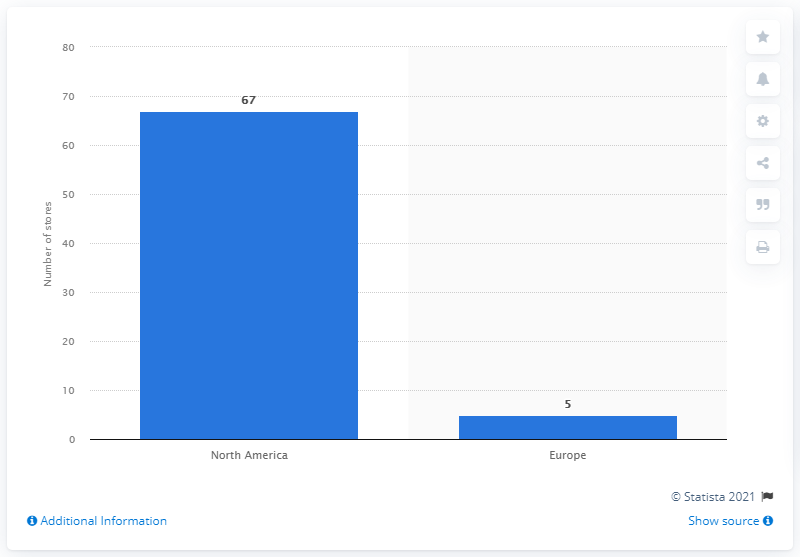Specify some key components in this picture. As of 2021, Polo Ralph Lauren operated a total of 67 Club Monaco stores. 